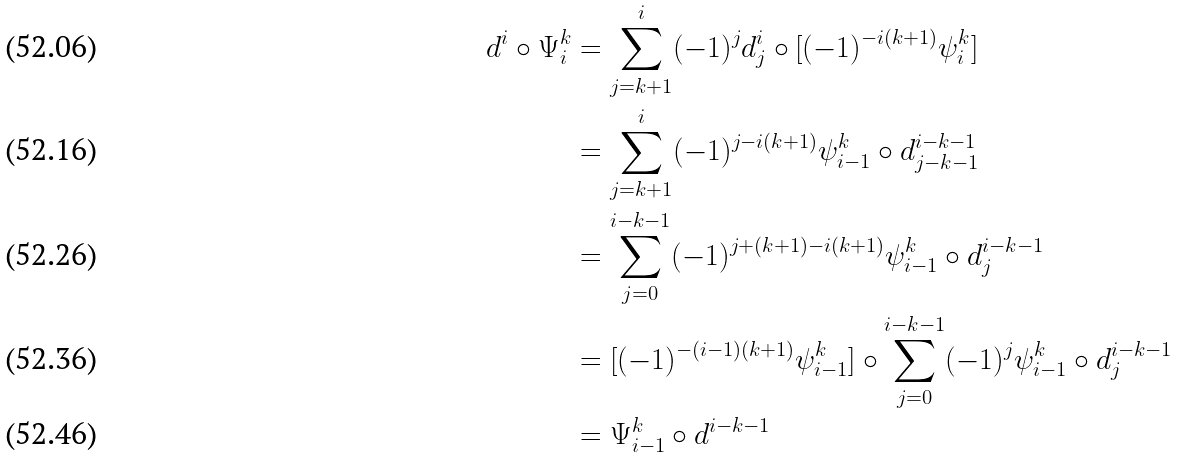<formula> <loc_0><loc_0><loc_500><loc_500>d ^ { i } \circ \Psi ^ { k } _ { i } & = \sum _ { j = k + 1 } ^ { i } ( - 1 ) ^ { j } d ^ { i } _ { j } \circ [ ( - 1 ) ^ { - i ( k + 1 ) } \psi ^ { k } _ { i } ] \\ & = \sum _ { j = k + 1 } ^ { i } ( - 1 ) ^ { j - i ( k + 1 ) } \psi ^ { k } _ { i - 1 } \circ d ^ { i - k - 1 } _ { j - k - 1 } \\ & = \sum _ { j = 0 } ^ { i - k - 1 } ( - 1 ) ^ { j + ( k + 1 ) - i ( k + 1 ) } \psi ^ { k } _ { i - 1 } \circ d ^ { i - k - 1 } _ { j } \\ & = [ ( - 1 ) ^ { - ( i - 1 ) ( k + 1 ) } \psi ^ { k } _ { i - 1 } ] \circ \sum _ { j = 0 } ^ { i - k - 1 } ( - 1 ) ^ { j } \psi ^ { k } _ { i - 1 } \circ d ^ { i - k - 1 } _ { j } \\ & = \Psi ^ { k } _ { i - 1 } \circ d ^ { i - k - 1 }</formula> 